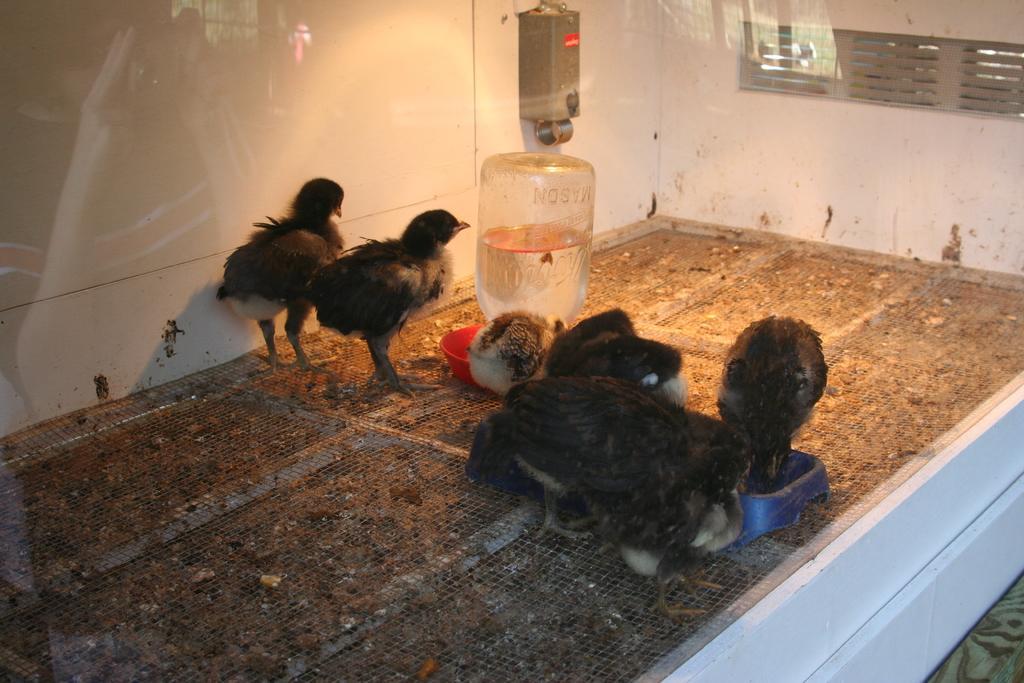How would you summarize this image in a sentence or two? In this picture there are birds in the center of the image and there is a water bottle in the center of the image, it seems to be a glass cage. 